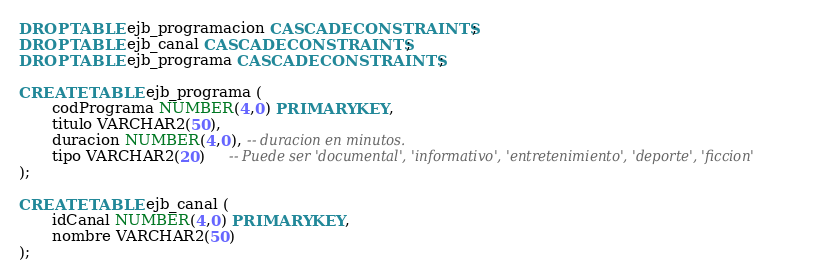<code> <loc_0><loc_0><loc_500><loc_500><_SQL_>DROP TABLE ejb_programacion CASCADE CONSTRAINTS;
DROP TABLE ejb_canal CASCADE CONSTRAINTS;
DROP TABLE ejb_programa CASCADE CONSTRAINTS;

CREATE TABLE ejb_programa (
       codPrograma NUMBER(4,0) PRIMARY KEY,
       titulo VARCHAR2(50),
       duracion NUMBER(4,0), -- duracion en minutos.
       tipo VARCHAR2(20)     -- Puede ser 'documental', 'informativo', 'entretenimiento', 'deporte', 'ficcion'
);

CREATE TABLE ejb_canal (
       idCanal NUMBER(4,0) PRIMARY KEY,
       nombre VARCHAR2(50)
);
</code> 